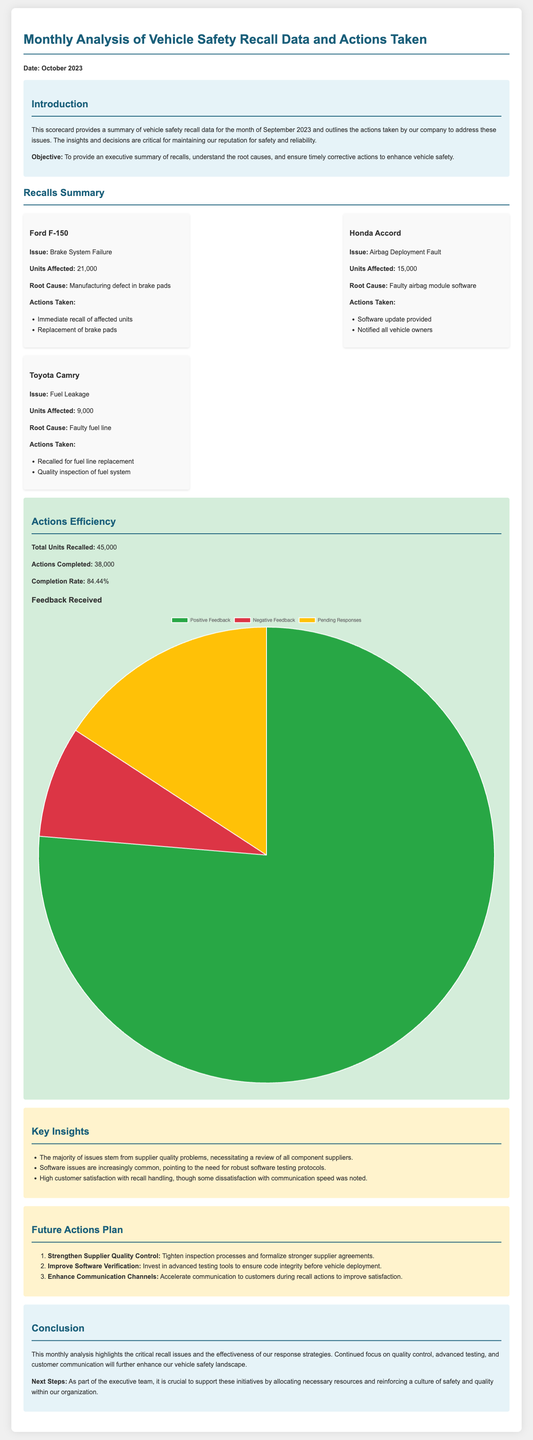What was the date of the scorecard? The scorecard provides the date in the introduction section, stating "Date: October 2023."
Answer: October 2023 How many units were affected in the Ford F-150 recall? The affected units for the Ford F-150 are listed as "21,000."
Answer: 21,000 What was the root cause of the Honda Accord recall? The document mentions the root cause for the Honda Accord as "Faulty airbag module software."
Answer: Faulty airbag module software What is the completion rate of the actions taken? The completion rate is provided as a percentage, calculated by the formula "Actions Completed / Total Units Recalled."
Answer: 84.44% What was the total number of recalls in September 2023? The total units recalled is specified as "45,000."
Answer: 45,000 Which model had the least number of units affected? The document lists the affected units, with the Toyota Camry having the least at "9,000."
Answer: Toyota Camry What is one of the key insights from the analysis? The insights section highlights issues, with one stating, "The majority of issues stem from supplier quality problems."
Answer: Supplier quality problems What action is suggested to improve software verification? The future actions plan suggests to "Invest in advanced testing tools to ensure code integrity."
Answer: Invest in advanced testing tools What is the total positive feedback recorded? The feedback distribution chart indicates "29,000" for positive feedback.
Answer: 29,000 